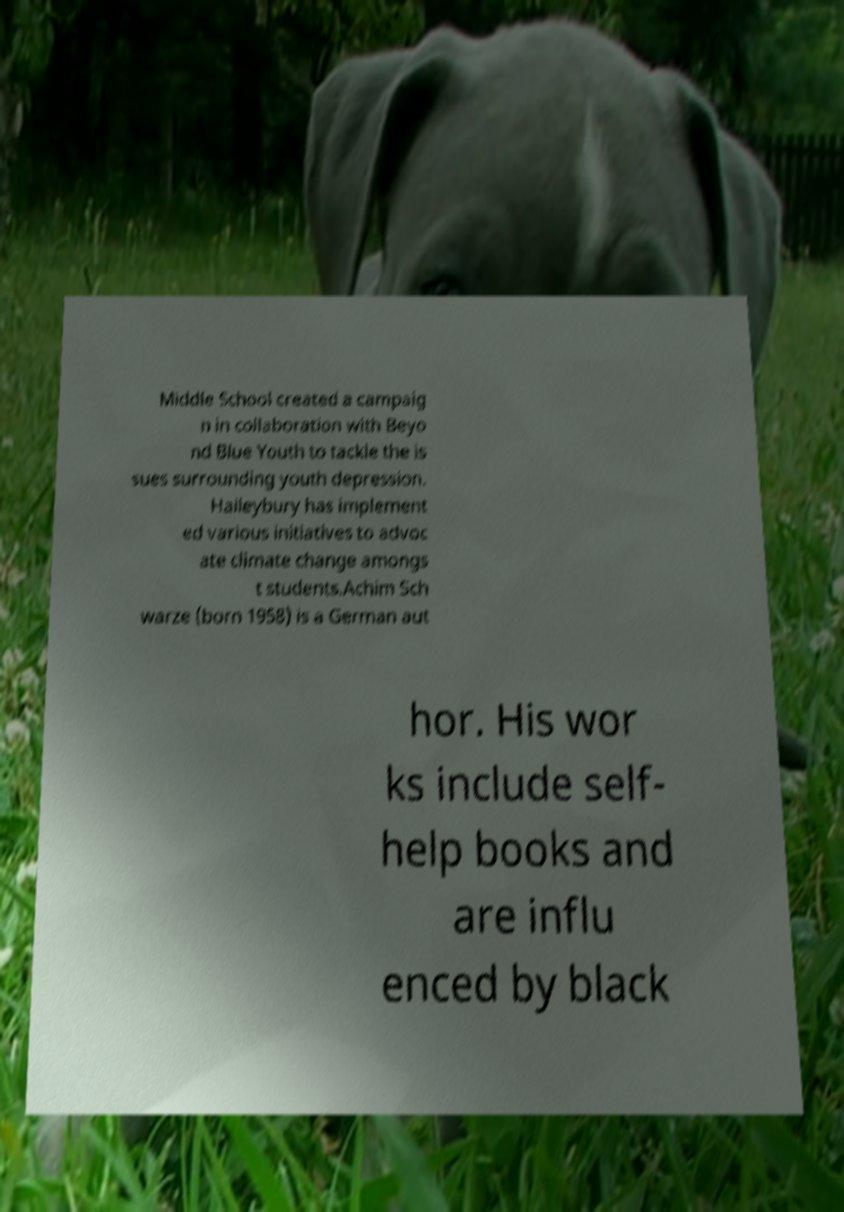Please identify and transcribe the text found in this image. Middle School created a campaig n in collaboration with Beyo nd Blue Youth to tackle the is sues surrounding youth depression. Haileybury has implement ed various initiatives to advoc ate climate change amongs t students.Achim Sch warze (born 1958) is a German aut hor. His wor ks include self- help books and are influ enced by black 